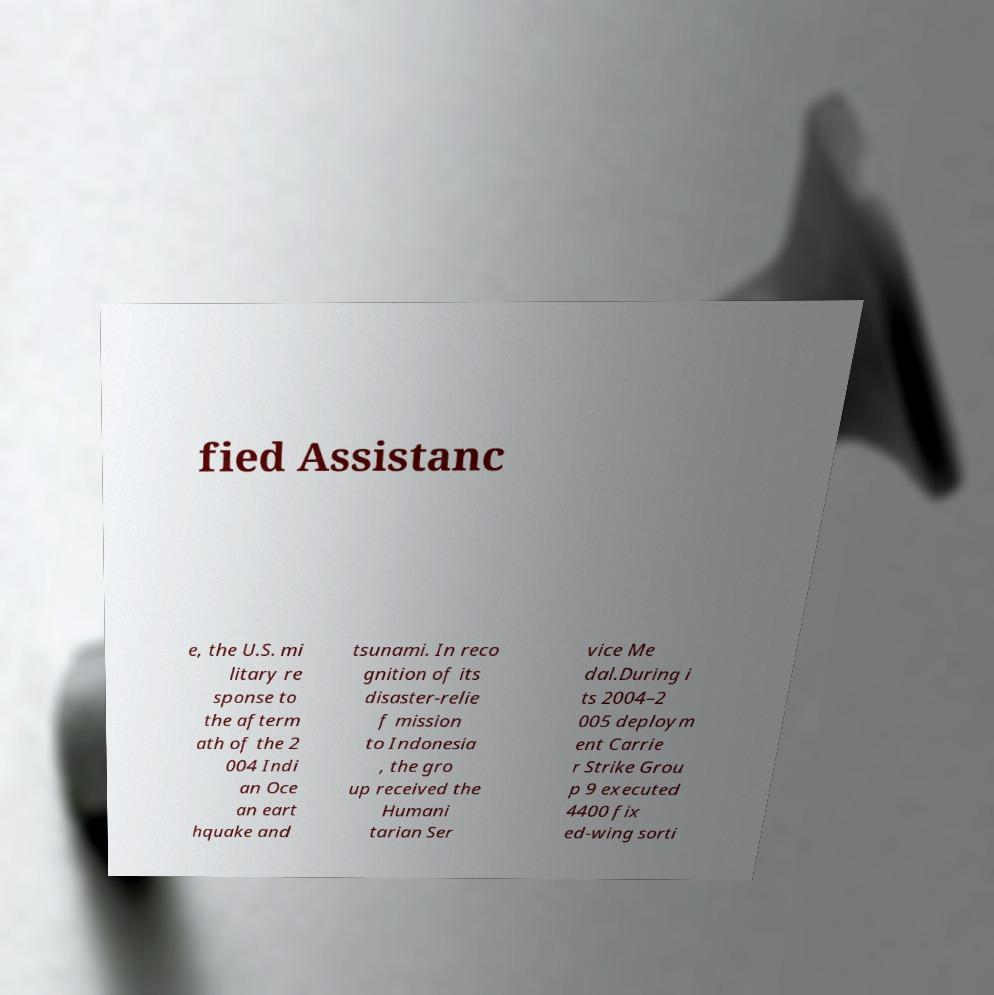Please read and relay the text visible in this image. What does it say? fied Assistanc e, the U.S. mi litary re sponse to the afterm ath of the 2 004 Indi an Oce an eart hquake and tsunami. In reco gnition of its disaster-relie f mission to Indonesia , the gro up received the Humani tarian Ser vice Me dal.During i ts 2004–2 005 deploym ent Carrie r Strike Grou p 9 executed 4400 fix ed-wing sorti 